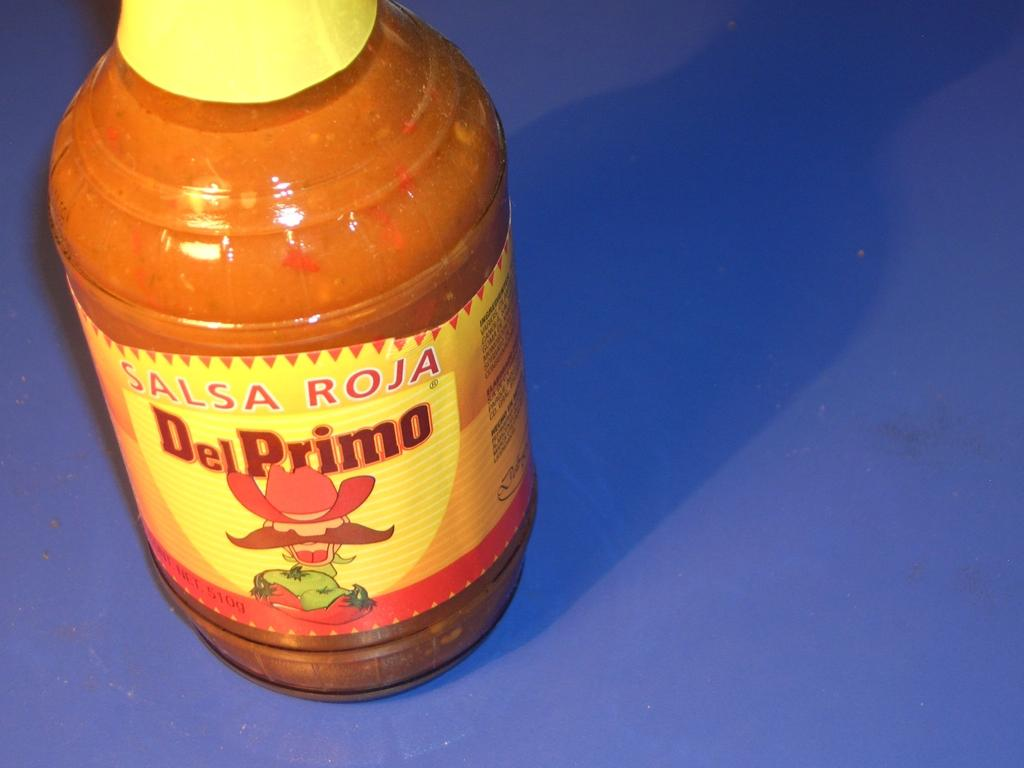<image>
Offer a succinct explanation of the picture presented. Orange and yellow bottle of Del Primo on a purple surface. 